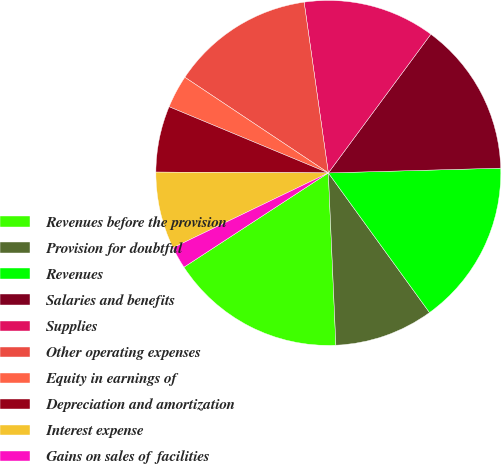<chart> <loc_0><loc_0><loc_500><loc_500><pie_chart><fcel>Revenues before the provision<fcel>Provision for doubtful<fcel>Revenues<fcel>Salaries and benefits<fcel>Supplies<fcel>Other operating expenses<fcel>Equity in earnings of<fcel>Depreciation and amortization<fcel>Interest expense<fcel>Gains on sales of facilities<nl><fcel>16.49%<fcel>9.28%<fcel>15.46%<fcel>14.43%<fcel>12.37%<fcel>13.4%<fcel>3.09%<fcel>6.19%<fcel>7.22%<fcel>2.06%<nl></chart> 